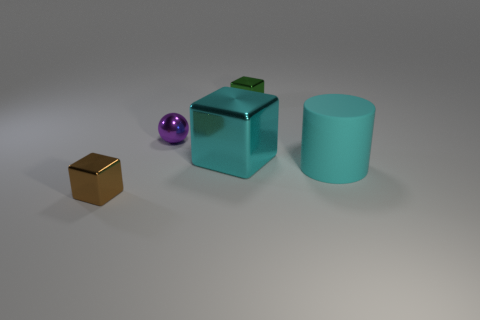What size is the green thing that is the same shape as the small brown metallic object?
Ensure brevity in your answer.  Small. What shape is the shiny thing that is to the left of the small purple thing?
Your answer should be very brief. Cube. What is the shape of the large shiny thing?
Offer a terse response. Cube. The cube that is the same color as the large rubber object is what size?
Provide a short and direct response. Large. Are there more green cubes than small brown matte cubes?
Your answer should be compact. Yes. Is the material of the large cyan cylinder the same as the tiny green cube?
Offer a terse response. No. How many matte objects are either large objects or things?
Your answer should be compact. 1. There is a cylinder that is the same size as the cyan shiny object; what color is it?
Provide a succinct answer. Cyan. How many other brown metal things are the same shape as the brown object?
Ensure brevity in your answer.  0. What number of blocks are small things or large yellow rubber objects?
Keep it short and to the point. 2. 